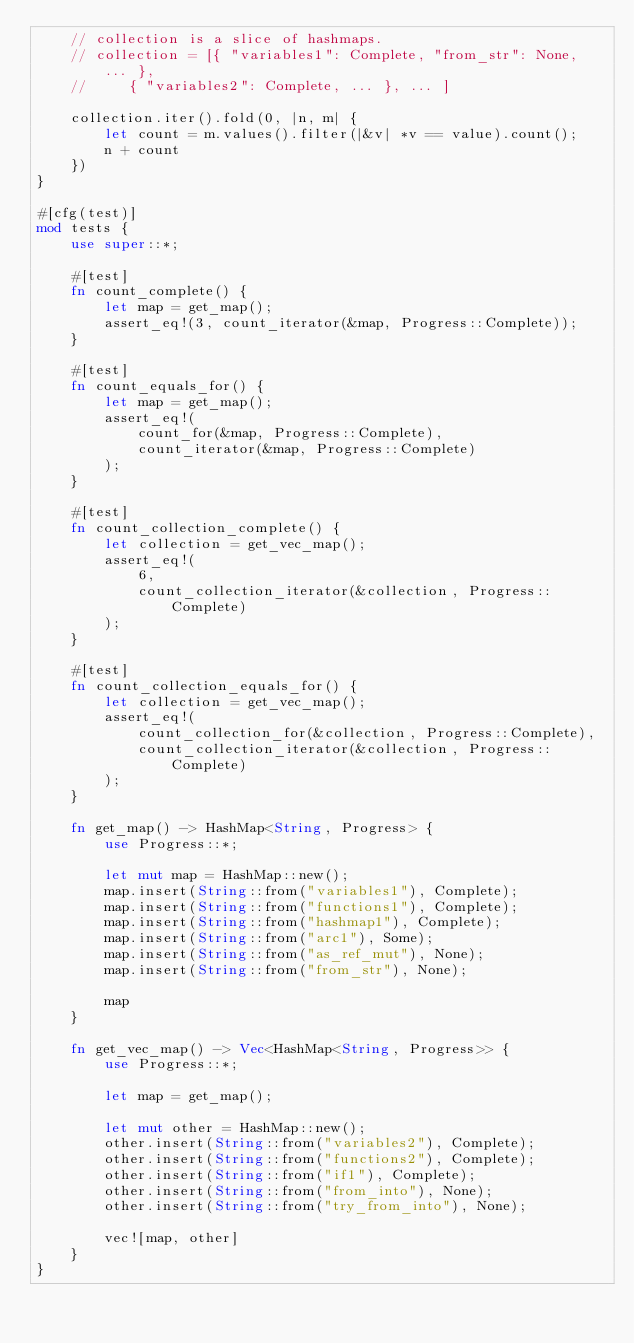Convert code to text. <code><loc_0><loc_0><loc_500><loc_500><_Rust_>    // collection is a slice of hashmaps.
    // collection = [{ "variables1": Complete, "from_str": None, ... },
    //     { "variables2": Complete, ... }, ... ]
    
    collection.iter().fold(0, |n, m| {
        let count = m.values().filter(|&v| *v == value).count();
        n + count
    })
}

#[cfg(test)]
mod tests {
    use super::*;

    #[test]
    fn count_complete() {
        let map = get_map();
        assert_eq!(3, count_iterator(&map, Progress::Complete));
    }

    #[test]
    fn count_equals_for() {
        let map = get_map();
        assert_eq!(
            count_for(&map, Progress::Complete),
            count_iterator(&map, Progress::Complete)
        );
    }

    #[test]
    fn count_collection_complete() {
        let collection = get_vec_map();
        assert_eq!(
            6,
            count_collection_iterator(&collection, Progress::Complete)
        );
    }

    #[test]
    fn count_collection_equals_for() {
        let collection = get_vec_map();
        assert_eq!(
            count_collection_for(&collection, Progress::Complete),
            count_collection_iterator(&collection, Progress::Complete)
        );
    }

    fn get_map() -> HashMap<String, Progress> {
        use Progress::*;

        let mut map = HashMap::new();
        map.insert(String::from("variables1"), Complete);
        map.insert(String::from("functions1"), Complete);
        map.insert(String::from("hashmap1"), Complete);
        map.insert(String::from("arc1"), Some);
        map.insert(String::from("as_ref_mut"), None);
        map.insert(String::from("from_str"), None);

        map
    }

    fn get_vec_map() -> Vec<HashMap<String, Progress>> {
        use Progress::*;

        let map = get_map();

        let mut other = HashMap::new();
        other.insert(String::from("variables2"), Complete);
        other.insert(String::from("functions2"), Complete);
        other.insert(String::from("if1"), Complete);
        other.insert(String::from("from_into"), None);
        other.insert(String::from("try_from_into"), None);

        vec![map, other]
    }
}
</code> 